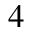Convert formula to latex. <formula><loc_0><loc_0><loc_500><loc_500>4</formula> 